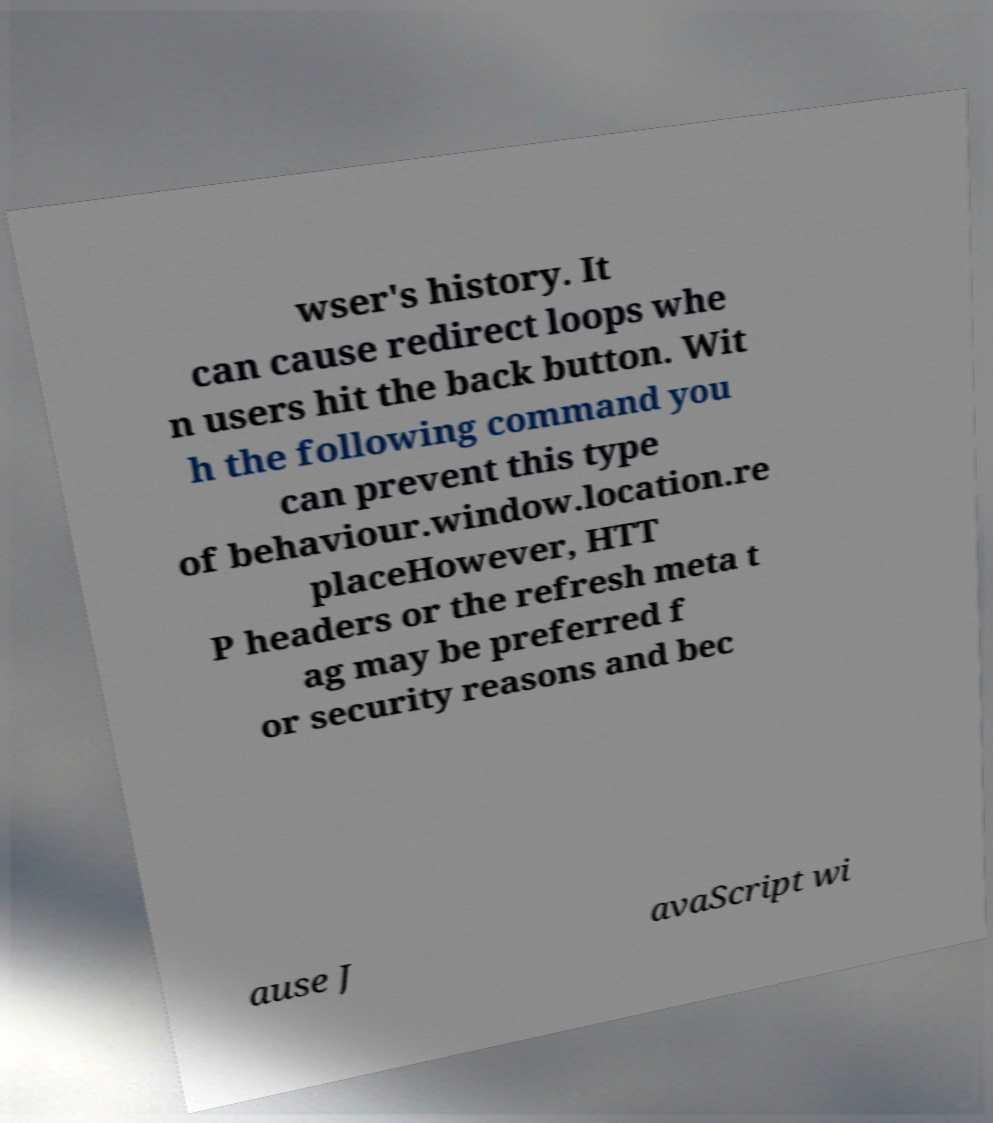Can you read and provide the text displayed in the image?This photo seems to have some interesting text. Can you extract and type it out for me? wser's history. It can cause redirect loops whe n users hit the back button. Wit h the following command you can prevent this type of behaviour.window.location.re placeHowever, HTT P headers or the refresh meta t ag may be preferred f or security reasons and bec ause J avaScript wi 